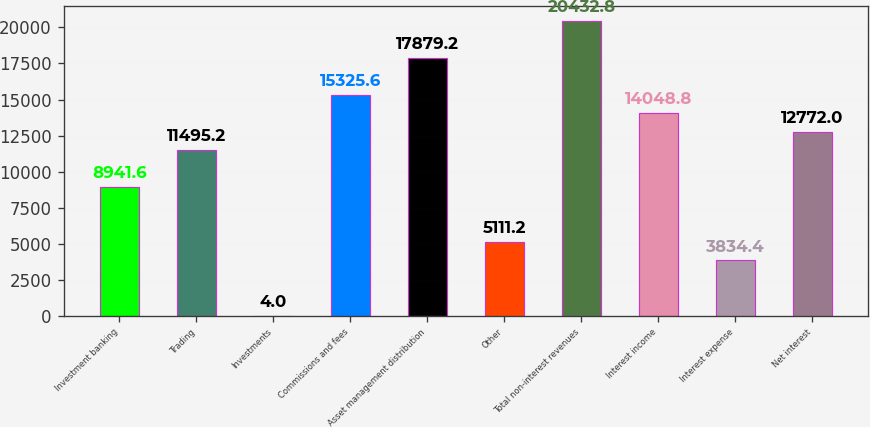Convert chart to OTSL. <chart><loc_0><loc_0><loc_500><loc_500><bar_chart><fcel>Investment banking<fcel>Trading<fcel>Investments<fcel>Commissions and fees<fcel>Asset management distribution<fcel>Other<fcel>Total non-interest revenues<fcel>Interest income<fcel>Interest expense<fcel>Net interest<nl><fcel>8941.6<fcel>11495.2<fcel>4<fcel>15325.6<fcel>17879.2<fcel>5111.2<fcel>20432.8<fcel>14048.8<fcel>3834.4<fcel>12772<nl></chart> 